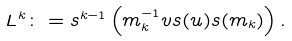<formula> <loc_0><loc_0><loc_500><loc_500>L ^ { k } \colon = s ^ { k - 1 } \left ( m _ { k } ^ { - 1 } v s ( u ) s ( m _ { k } ) \right ) .</formula> 